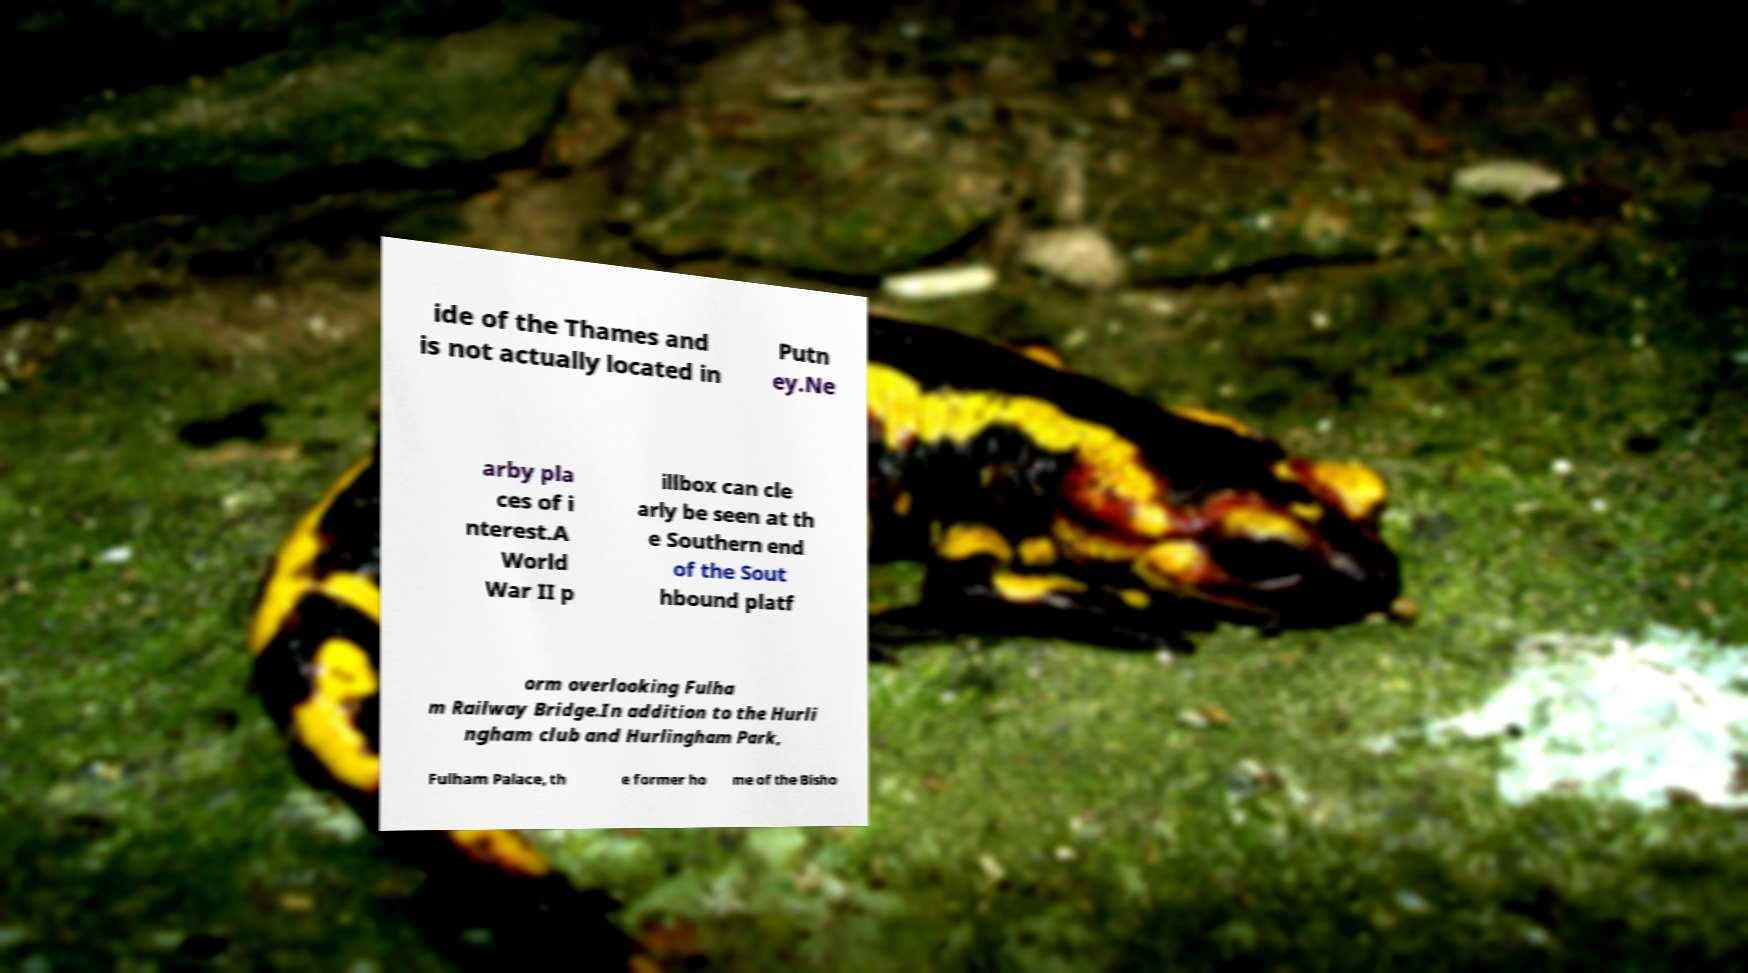Please identify and transcribe the text found in this image. ide of the Thames and is not actually located in Putn ey.Ne arby pla ces of i nterest.A World War II p illbox can cle arly be seen at th e Southern end of the Sout hbound platf orm overlooking Fulha m Railway Bridge.In addition to the Hurli ngham club and Hurlingham Park, Fulham Palace, th e former ho me of the Bisho 